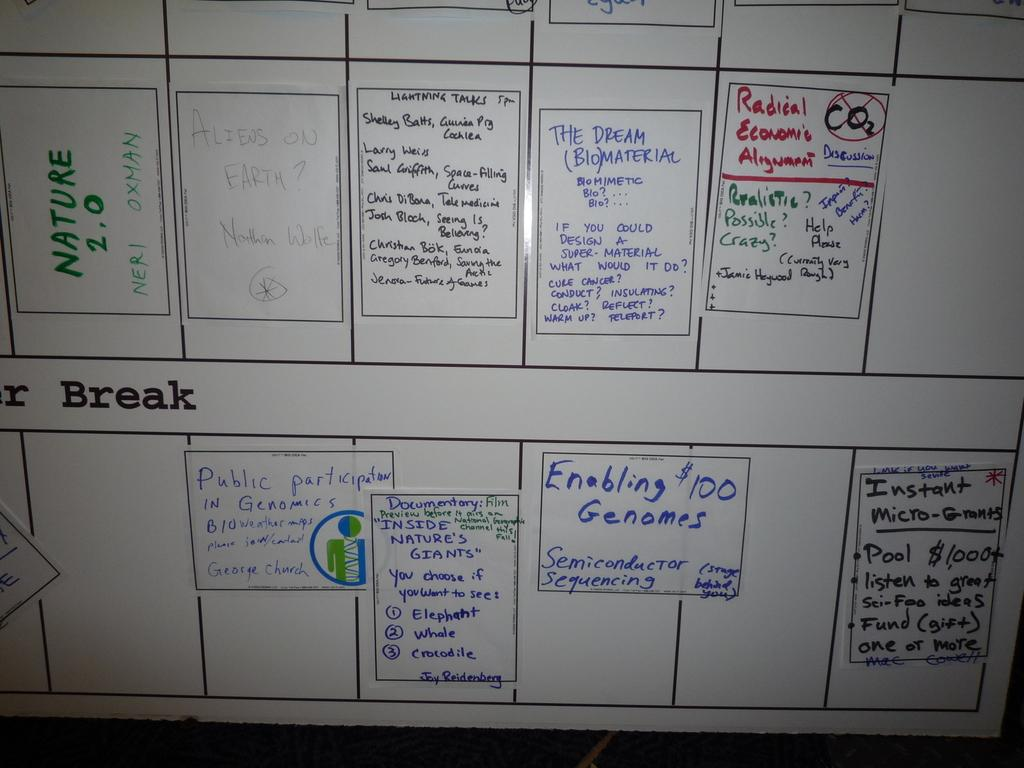Provide a one-sentence caption for the provided image. A large whiteboard reveals plan for summer break. 